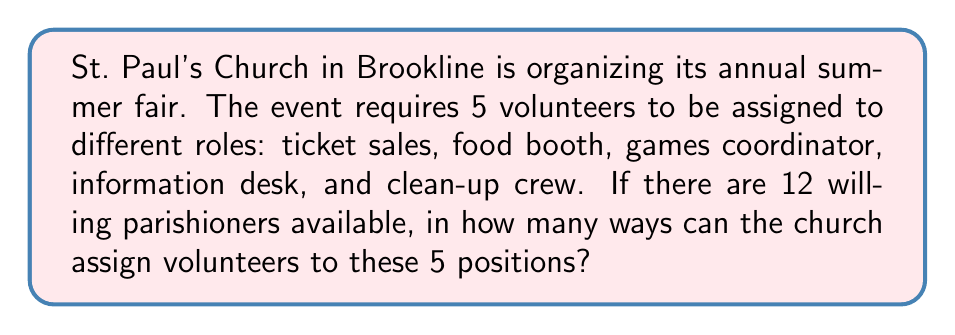Could you help me with this problem? Let's approach this step-by-step:

1) This is a permutation problem because the order matters (each role is distinct) and we are selecting volunteers without replacement (one person can't do multiple roles simultaneously).

2) We are choosing 5 people out of 12 to fill 5 distinct positions. This scenario is described by the permutation formula:

   $$P(n,r) = \frac{n!}{(n-r)!}$$

   Where $n$ is the total number of people to choose from, and $r$ is the number of positions to fill.

3) In this case, $n = 12$ (total parishioners) and $r = 5$ (roles to fill).

4) Let's substitute these values into our formula:

   $$P(12,5) = \frac{12!}{(12-5)!} = \frac{12!}{7!}$$

5) Now, let's calculate this:
   
   $$\frac{12!}{7!} = \frac{12 \times 11 \times 10 \times 9 \times 8 \times 7!}{7!}$$

6) The $7!$ cancels out in the numerator and denominator:

   $$12 \times 11 \times 10 \times 9 \times 8 = 95,040$$

Therefore, there are 95,040 ways to assign 5 volunteers to the 5 positions from the group of 12 parishioners.
Answer: 95,040 